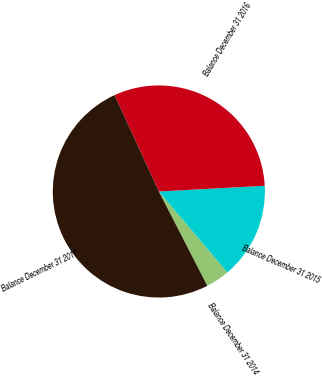Convert chart to OTSL. <chart><loc_0><loc_0><loc_500><loc_500><pie_chart><fcel>Balance December 31 2014<fcel>Balance December 31 2015<fcel>Balance December 31 2016<fcel>Balance December 31 2017<nl><fcel>3.64%<fcel>14.67%<fcel>31.01%<fcel>50.69%<nl></chart> 